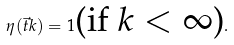Convert formula to latex. <formula><loc_0><loc_0><loc_500><loc_500>\eta ( \vec { t } k ) = 1 \text {(if $k<\infty$)} .</formula> 